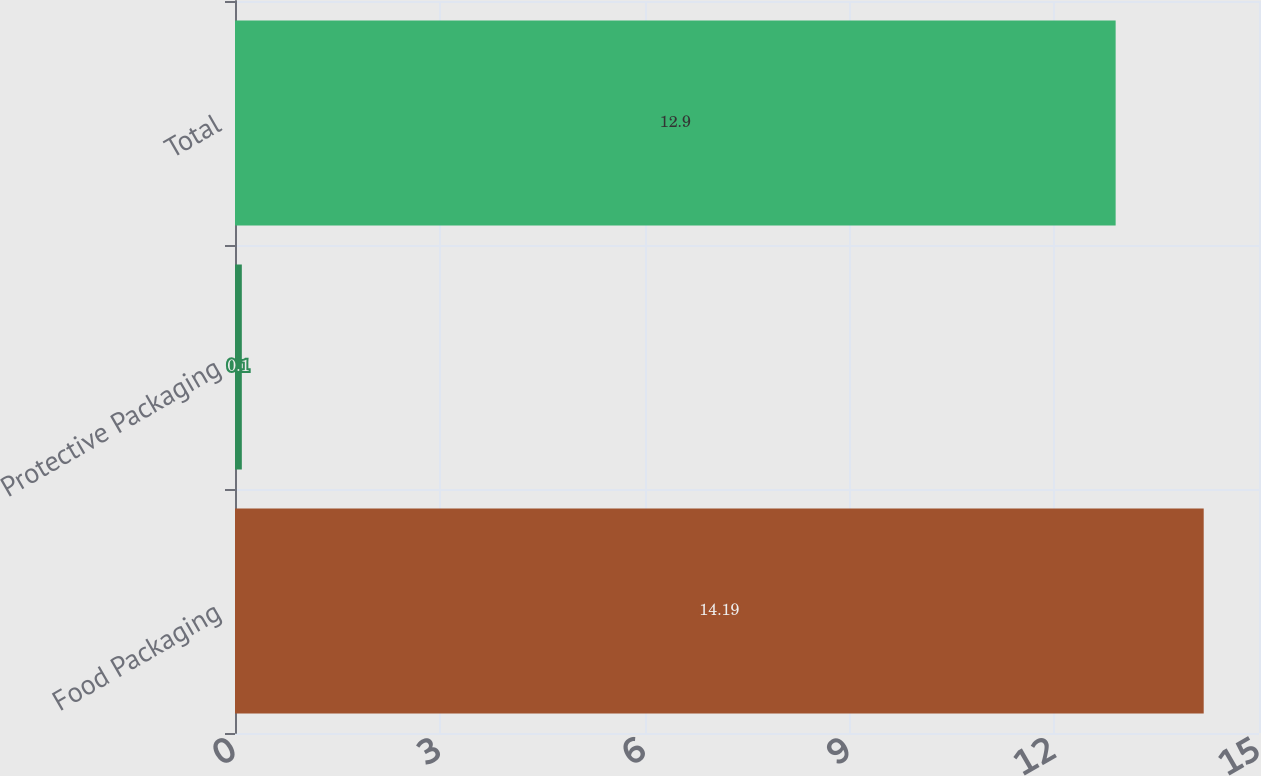Convert chart. <chart><loc_0><loc_0><loc_500><loc_500><bar_chart><fcel>Food Packaging<fcel>Protective Packaging<fcel>Total<nl><fcel>14.19<fcel>0.1<fcel>12.9<nl></chart> 